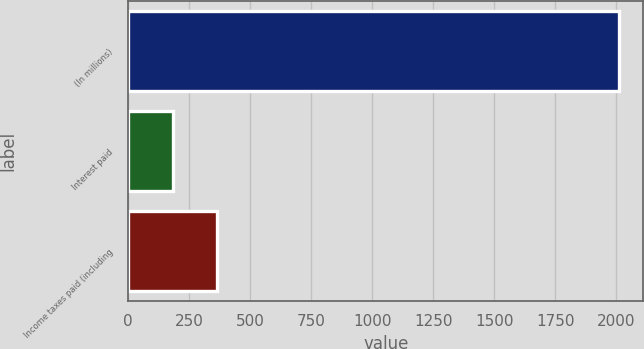<chart> <loc_0><loc_0><loc_500><loc_500><bar_chart><fcel>(In millions)<fcel>Interest paid<fcel>Income taxes paid (including<nl><fcel>2010<fcel>182<fcel>364.8<nl></chart> 